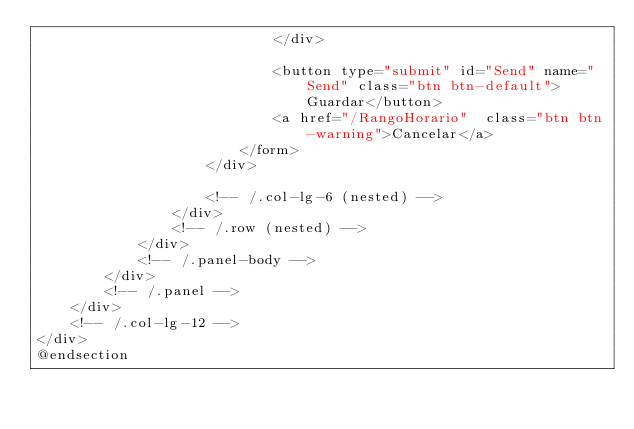<code> <loc_0><loc_0><loc_500><loc_500><_PHP_>                            </div>

                            <button type="submit" id="Send" name="Send" class="btn btn-default">Guardar</button>
                            <a href="/RangoHorario"  class="btn btn-warning">Cancelar</a>
                        </form>
                    </div>

                    <!-- /.col-lg-6 (nested) -->
                </div>
                <!-- /.row (nested) -->
            </div>
            <!-- /.panel-body -->
        </div>
        <!-- /.panel -->
    </div>
    <!-- /.col-lg-12 -->
</div>
@endsection</code> 